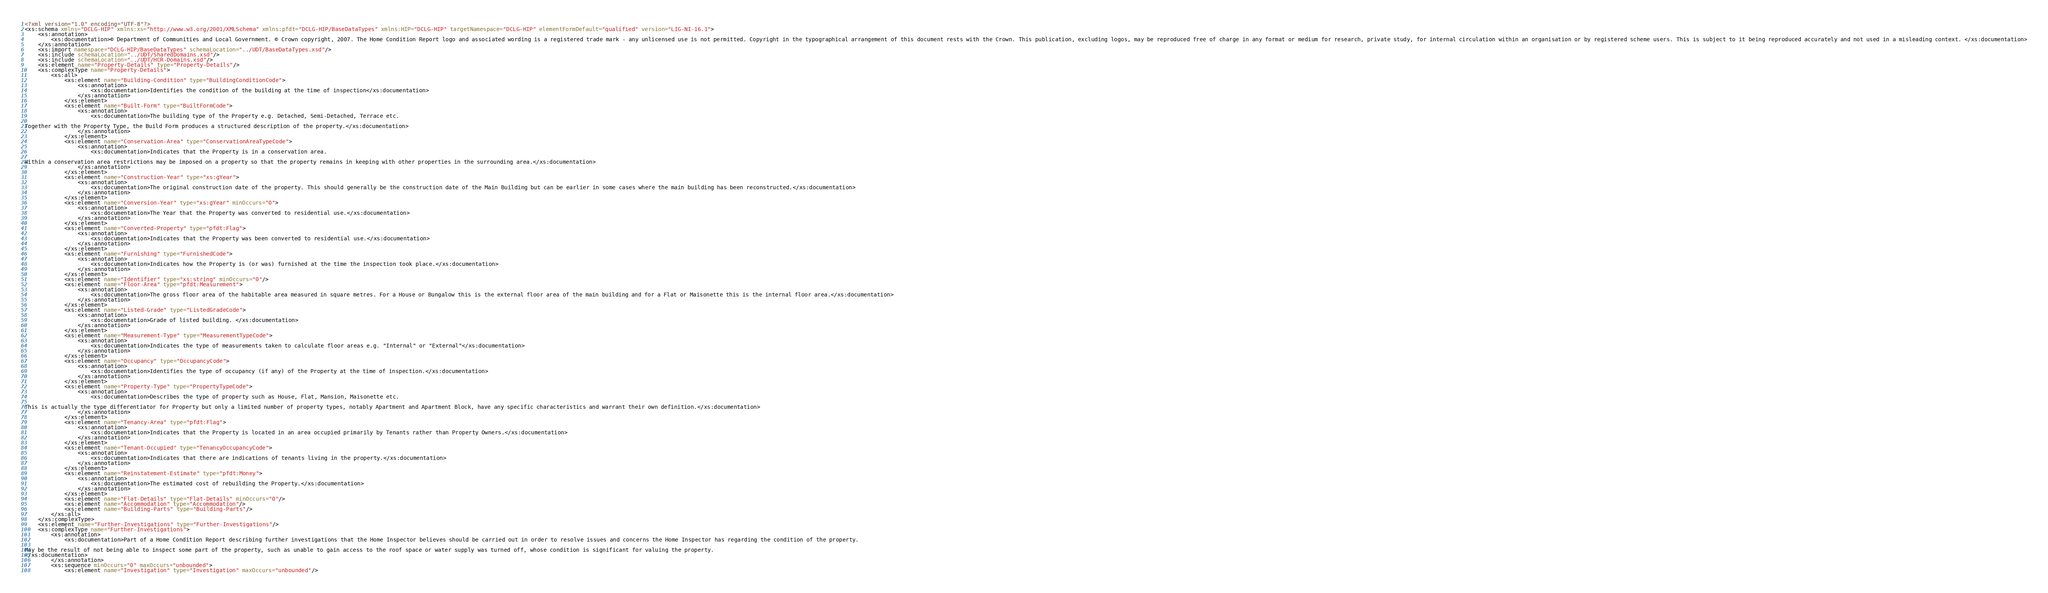Convert code to text. <code><loc_0><loc_0><loc_500><loc_500><_XML_><?xml version="1.0" encoding="UTF-8"?>
<xs:schema xmlns="DCLG-HIP" xmlns:xs="http://www.w3.org/2001/XMLSchema" xmlns:pfdt="DCLG-HIP/BaseDataTypes" xmlns:HIP="DCLG-HIP" targetNamespace="DCLG-HIP" elementFormDefault="qualified" version="LIG-NI-16.1">
	<xs:annotation>
		<xs:documentation>© Department of Communities and Local Government. © Crown copyright, 2007. The Home Condition Report logo and associated wording is a registered trade mark - any unlicensed use is not permitted. Copyright in the typographical arrangement of this document rests with the Crown. This publication, excluding logos, may be reproduced free of charge in any format or medium for research, private study, for internal circulation within an organisation or by registered scheme users. This is subject to it being reproduced accurately and not used in a misleading context. </xs:documentation>
	</xs:annotation>
	<xs:import namespace="DCLG-HIP/BaseDataTypes" schemaLocation="../UDT/BaseDataTypes.xsd"/>
	<xs:include schemaLocation="../UDT/SharedDomains.xsd"/>
	<xs:include schemaLocation="../UDT/HCR-Domains.xsd"/>
	<xs:element name="Property-Details" type="Property-Details"/>
	<xs:complexType name="Property-Details">
		<xs:all>
			<xs:element name="Building-Condition" type="BuildingConditionCode">
				<xs:annotation>
					<xs:documentation>Identifies the condition of the building at the time of inspection</xs:documentation>
				</xs:annotation>
			</xs:element>
			<xs:element name="Built-Form" type="BuiltFormCode">
				<xs:annotation>
					<xs:documentation>The building type of the Property e.g. Detached, Semi-Detached, Terrace etc.

Together with the Property Type, the Build Form produces a structured description of the property.</xs:documentation>
				</xs:annotation>
			</xs:element>
			<xs:element name="Conservation-Area" type="ConservationAreaTypeCode">
				<xs:annotation>
					<xs:documentation>Indicates that the Property is in a conservation area. 

Within a conservation area restrictions may be imposed on a property so that the property remains in keeping with other properties in the surrounding area.</xs:documentation>
				</xs:annotation>
			</xs:element>
			<xs:element name="Construction-Year" type="xs:gYear">
				<xs:annotation>
					<xs:documentation>The original construction date of the property. This should generally be the construction date of the Main Building but can be earlier in some cases where the main building has been reconstructed.</xs:documentation>
				</xs:annotation>
			</xs:element>
			<xs:element name="Conversion-Year" type="xs:gYear" minOccurs="0">
				<xs:annotation>
					<xs:documentation>The Year that the Property was converted to residential use.</xs:documentation>
				</xs:annotation>
			</xs:element>
			<xs:element name="Converted-Property" type="pfdt:Flag">
				<xs:annotation>
					<xs:documentation>Indicates that the Property was been converted to residential use.</xs:documentation>
				</xs:annotation>
			</xs:element>
			<xs:element name="Furnishing" type="FurnishedCode">
				<xs:annotation>
					<xs:documentation>Indicates how the Property is (or was) furnished at the time the inspection took place.</xs:documentation>
				</xs:annotation>
			</xs:element>
			<xs:element name="Identifier" type="xs:string" minOccurs="0"/>
			<xs:element name="Floor-Area" type="pfdt:Measurement">
				<xs:annotation>
					<xs:documentation>The gross floor area of the habitable area measured in square metres. For a House or Bungalow this is the external floor area of the main building and for a Flat or Maisonette this is the internal floor area.</xs:documentation>
				</xs:annotation>
			</xs:element>
			<xs:element name="Listed-Grade" type="ListedGradeCode">
				<xs:annotation>
					<xs:documentation>Grade of listed building. </xs:documentation>
				</xs:annotation>
			</xs:element>
			<xs:element name="Measurement-Type" type="MeasurementTypeCode">
				<xs:annotation>
					<xs:documentation>Indicates the type of measurements taken to calculate floor areas e.g. "Internal" or "External"</xs:documentation>
				</xs:annotation>
			</xs:element>
			<xs:element name="Occupancy" type="OccupancyCode">
				<xs:annotation>
					<xs:documentation>Identifies the type of occupancy (if any) of the Property at the time of inspection.</xs:documentation>
				</xs:annotation>
			</xs:element>
			<xs:element name="Property-Type" type="PropertyTypeCode">
				<xs:annotation>
					<xs:documentation>Describes the type of property such as House, Flat, Mansion, Maisonette etc.

This is actually the type differentiator for Property but only a limited number of property types, notably Apartment and Apartment Block, have any specific characteristics and warrant their own definition.</xs:documentation>
				</xs:annotation>
			</xs:element>
			<xs:element name="Tenancy-Area" type="pfdt:Flag">
				<xs:annotation>
					<xs:documentation>Indicates that the Property is located in an area occupied primarily by Tenants rather than Property Owners.</xs:documentation>
				</xs:annotation>
			</xs:element>
			<xs:element name="Tenant-Occupied" type="TenancyOccupancyCode">
				<xs:annotation>
					<xs:documentation>Indicates that there are indications of tenants living in the property.</xs:documentation>
				</xs:annotation>
			</xs:element>
			<xs:element name="Reinstatement-Estimate" type="pfdt:Money">
				<xs:annotation>
					<xs:documentation>The estimated cost of rebuilding the Property.</xs:documentation>
				</xs:annotation>
			</xs:element>
			<xs:element name="Flat-Details" type="Flat-Details" minOccurs="0"/>
			<xs:element name="Accommodation" type="Accommodation"/>
			<xs:element name="Building-Parts" type="Building-Parts"/>
		</xs:all>
	</xs:complexType>
	<xs:element name="Further-Investigations" type="Further-Investigations"/>
	<xs:complexType name="Further-Investigations">
		<xs:annotation>
			<xs:documentation>Part of a Home Condition Report describing further investigations that the Home Inspector believes should be carried out in order to resolve issues and concerns the Home Inspector has regarding the condition of the property. 

May be the result of not being able to inspect some part of the property, such as unable to gain access to the roof space or water supply was turned off, whose condition is significant for valuing the property.
</xs:documentation>
		</xs:annotation>
		<xs:sequence minOccurs="0" maxOccurs="unbounded">
			<xs:element name="Investigation" type="Investigation" maxOccurs="unbounded"/></code> 